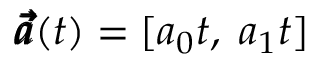<formula> <loc_0><loc_0><loc_500><loc_500>\pm b { \vec { a } } ( t ) = [ a _ { 0 } t , \, a _ { 1 } t ]</formula> 